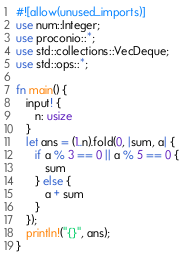Convert code to text. <code><loc_0><loc_0><loc_500><loc_500><_Rust_>#![allow(unused_imports)]
use num::Integer;
use proconio::*;
use std::collections::VecDeque;
use std::ops::*;

fn main() {
   input! {
      n: usize
   }
   let ans = (1..n).fold(0, |sum, a| {
      if a % 3 == 0 || a % 5 == 0 {
         sum
      } else {
         a + sum
      }
   });
   println!("{}", ans);
}
</code> 